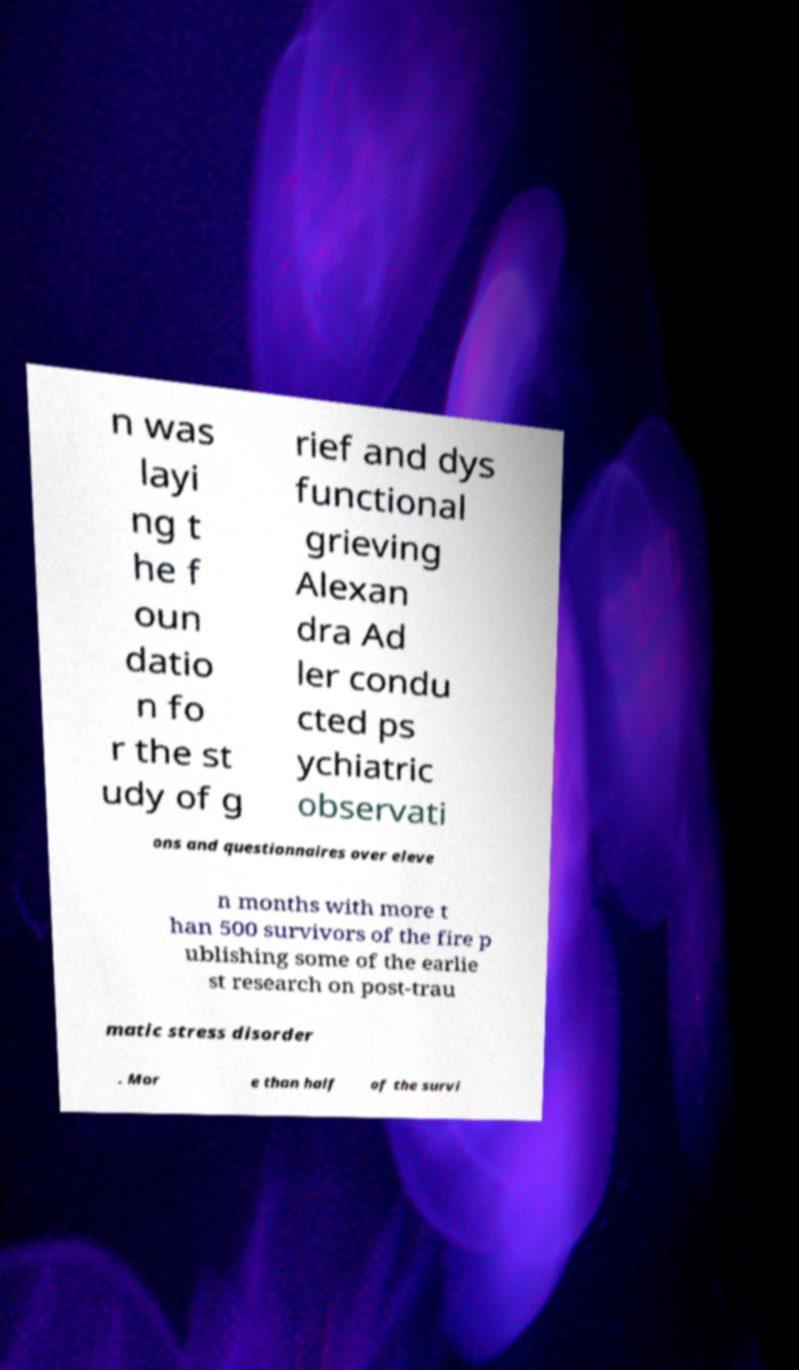Could you extract and type out the text from this image? n was layi ng t he f oun datio n fo r the st udy of g rief and dys functional grieving Alexan dra Ad ler condu cted ps ychiatric observati ons and questionnaires over eleve n months with more t han 500 survivors of the fire p ublishing some of the earlie st research on post-trau matic stress disorder . Mor e than half of the survi 